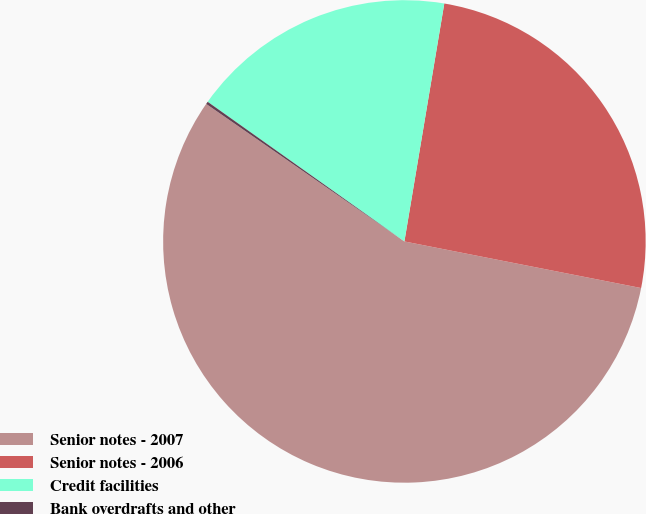Convert chart to OTSL. <chart><loc_0><loc_0><loc_500><loc_500><pie_chart><fcel>Senior notes - 2007<fcel>Senior notes - 2006<fcel>Credit facilities<fcel>Bank overdrafts and other<nl><fcel>56.56%<fcel>25.45%<fcel>17.82%<fcel>0.17%<nl></chart> 